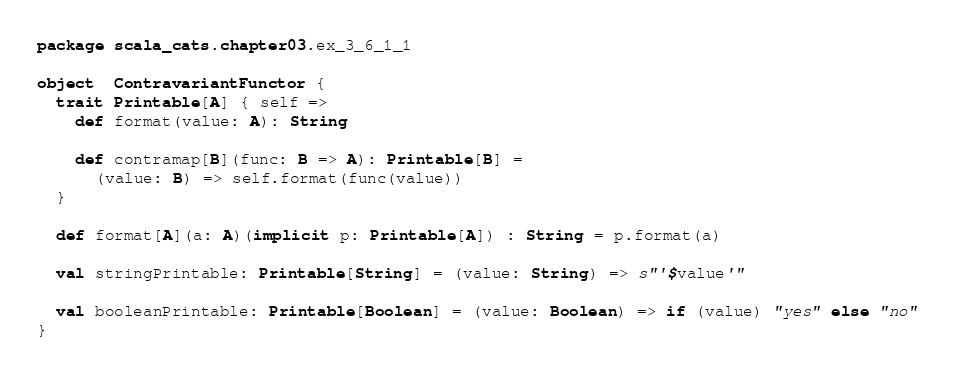Convert code to text. <code><loc_0><loc_0><loc_500><loc_500><_Scala_>package scala_cats.chapter03.ex_3_6_1_1

object  ContravariantFunctor {
  trait Printable[A] { self =>
    def format(value: A): String

    def contramap[B](func: B => A): Printable[B] =
      (value: B) => self.format(func(value))
  }

  def format[A](a: A)(implicit p: Printable[A]) : String = p.format(a)

  val stringPrintable: Printable[String] = (value: String) => s"'$value'"

  val booleanPrintable: Printable[Boolean] = (value: Boolean) => if (value) "yes" else "no"
}
</code> 